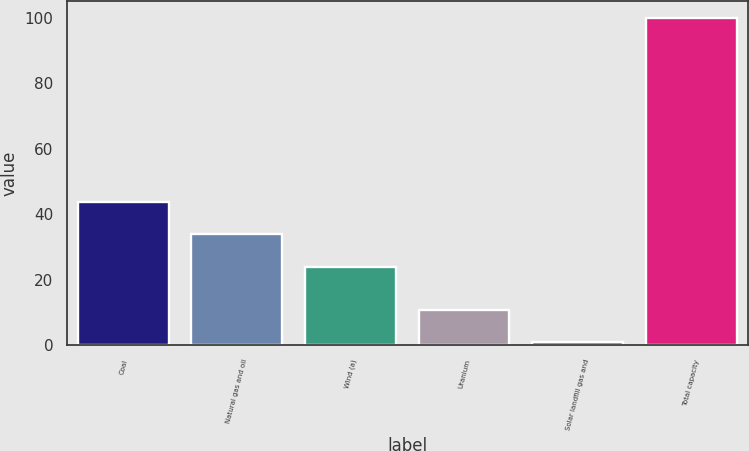<chart> <loc_0><loc_0><loc_500><loc_500><bar_chart><fcel>Coal<fcel>Natural gas and oil<fcel>Wind (a)<fcel>Uranium<fcel>Solar landfill gas and<fcel>Total capacity<nl><fcel>43.8<fcel>33.9<fcel>24<fcel>10.9<fcel>1<fcel>100<nl></chart> 